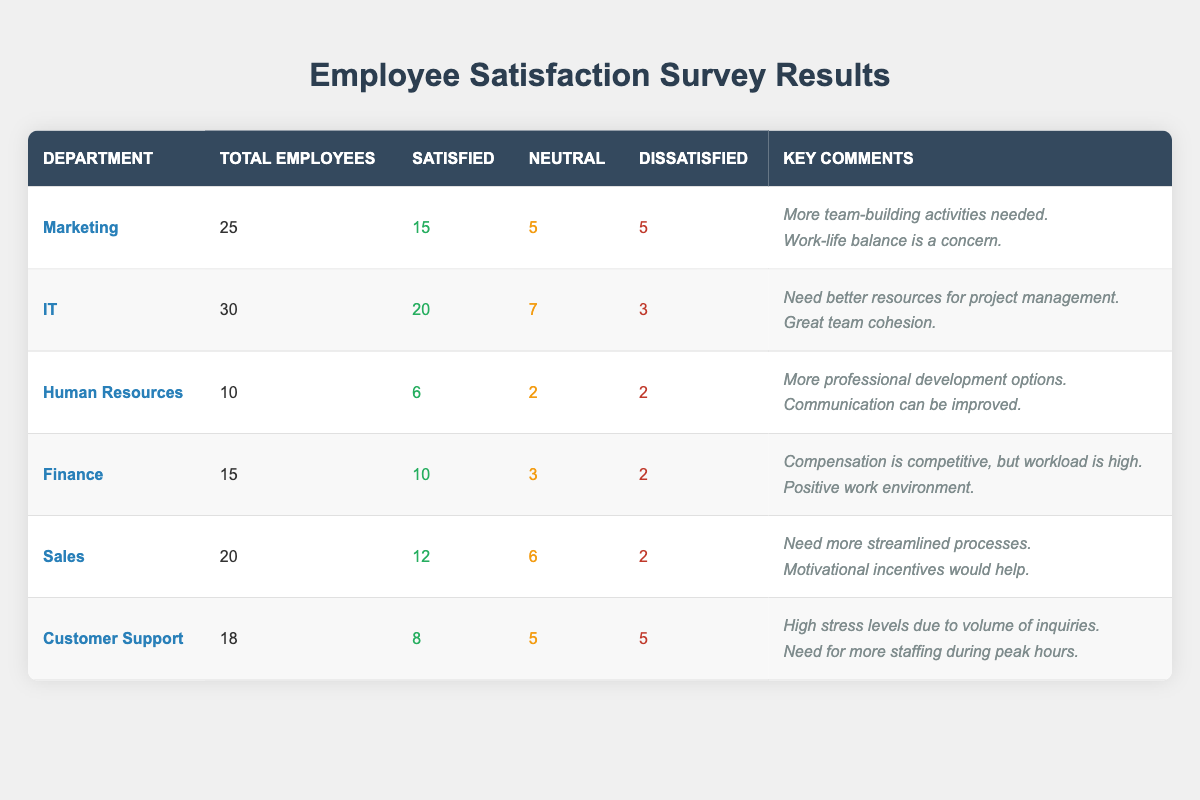What is the total number of employees in the Marketing department? The table lists the Marketing department with a total employee count of 25.
Answer: 25 How many employees in the IT department are satisfied? The IT department shows 20 employees are satisfied based on the survey results.
Answer: 20 What is the ratio of satisfied to dissatisfied employees in Human Resources? In Human Resources, there are 6 satisfied and 2 dissatisfied employees. The ratio is 6:2, which can be simplified to 3:1.
Answer: 3:1 Which department has the highest number of dissatisfied employees? The Customer Support department has 5 dissatisfied employees, which is the most of any department compared to the others listed.
Answer: Customer Support What is the average satisfaction rating across all departments? To find the average, we total the satisfied employees: 15 + 20 + 6 + 10 + 12 + 8 = 71. Then divide by the number of departments (6): 71 / 6 = 11.83, rounded to the nearest whole number is 12.
Answer: 12 Is it true that the Finance department has more satisfied employees than the Customer Support department? The Finance department has 10 satisfied employees, while the Customer Support department has 8, thus confirming that the Finance department has more satisfied employees.
Answer: Yes How many total employees across all departments are satisfied? By adding all satisfied figures: 15 (Marketing) + 20 (IT) + 6 (HR) + 10 (Finance) + 12 (Sales) + 8 (Customer Support) = 71 satisfied employees.
Answer: 71 Which department is the only one with a smaller number of total employees than Sales? Sales has 20 total employees, and Human Resources has the least with 10 total employees, which is less than Sales.
Answer: Human Resources What percentage of the IT department’s employees are neutral? The IT department has 30 employees, with 7 being neutral. The percentage is calculated as (7/30) × 100, which is approximately 23.33%, rounded to the nearest whole number gives 23%.
Answer: 23% Compare the number of neutral employees in Marketing and Customer Support. Which department has more? Marketing has 5 neutral employees, while Customer Support has 5 as well. Hence, both departments have an equal number of neutral employees.
Answer: Equal 